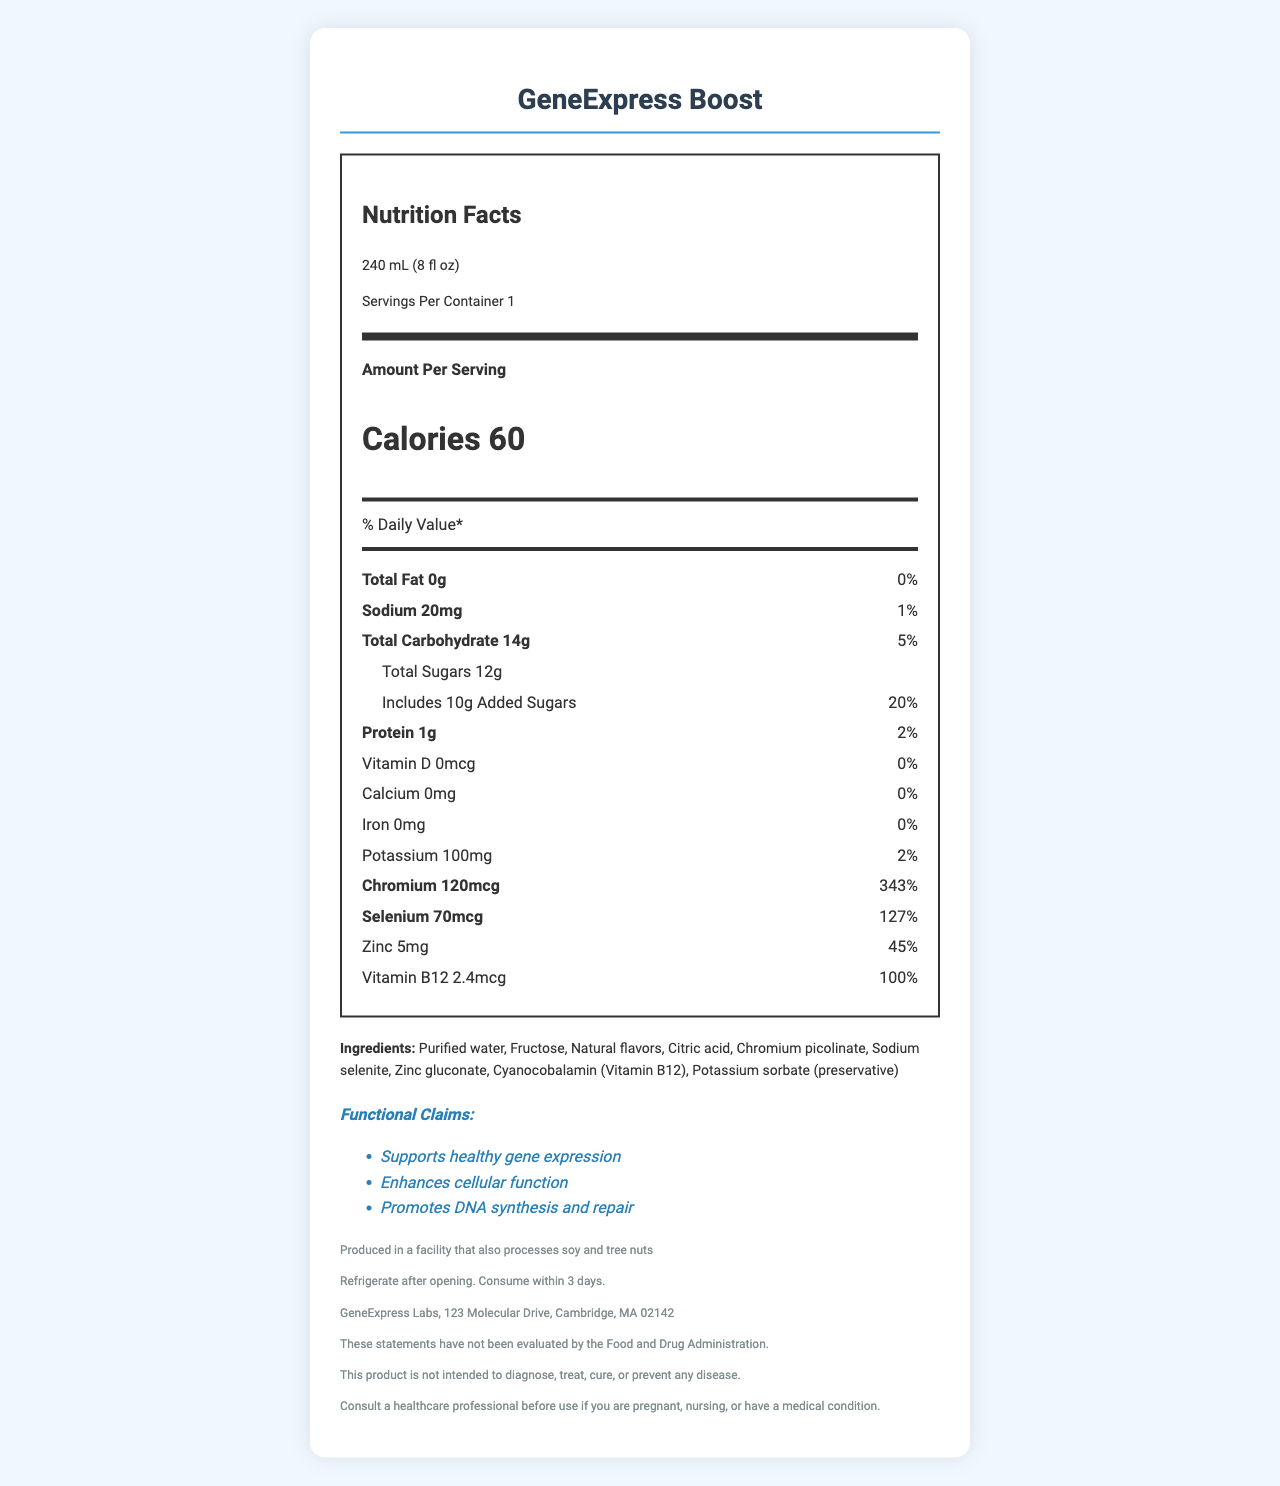what is the serving size of GeneExpress Boost? The serving size is explicitly stated as 240 mL (8 fl oz) in the document's serving information.
Answer: 240 mL (8 fl oz) how many calories are in one serving of GeneExpress Boost? The calorie content per serving is listed as 60 calories in the amount per serving section.
Answer: 60 what percentage of the daily value of chromium does one serving provide? The daily value percentage for chromium is given as 343% in the nutrient section.
Answer: 343% how much selenium is in one serving? The amount of selenium per serving is listed as 70 mcg in the nutrient section.
Answer: 70 mcg which ingredient is used as a preservative in GeneExpress Boost? The ingredients list in the document includes potassium sorbate (preservative).
Answer: Potassium sorbate True or False: GeneExpress Boost contains added sugars The document specifies that the beverage includes 10g of added sugars.
Answer: True which mineral has the highest daily value percentage in GeneExpress Boost? A. Selenium B. Chromium C. Zinc D. Potassium According to the nutrient section, chromium has the highest daily value percentage at 343%.
Answer: B which of the following is NOT a functional claim of GeneExpress Boost? A. Supports healthy gene expression B. Enhances cellular function C. Promotes weight loss D. Promotes DNA synthesis and repair The functional claims listed are: Supports healthy gene expression, Enhances cellular function, and Promotes DNA synthesis and repair; "Promotes weight loss" is not listed.
Answer: C do I need to consult a healthcare professional before using it if I am pregnant? The disclaimers advise consulting a healthcare professional before use if you are pregnant.
Answer: Yes summarize the main idea of the document The document provides comprehensive information on the nutritional value, ingredients, functional claims, and consumption instructions of the GeneExpress Boost beverage, emphasizing its role in supporting gene expression and cellular health.
Answer: GeneExpress Boost is a functional beverage designed to support healthy gene expression, enhance cellular function, and promote DNA synthesis and repair. It contains significant amounts of chromium, selenium, and other essential nutrients. The beverage provides detailed nutrition facts, ingredients, functional claims, and disclaimers about its production and usage. what is the daily value percentage of potassium in one serving? The daily value percentage for potassium is given as 2% in the nutrient section.
Answer: 2% how long should GeneExpress Boost be consumed after opening? The storage instructions specify that the beverage should be consumed within 3 days after opening.
Answer: Within 3 days what type of information cannot be determined from the document? The document does not provide specific scientific details or mechanisms explaining how the beverage supports gene expression.
Answer: The exact mechanism by which GeneExpress Boost supports gene expression cannot be determined. 